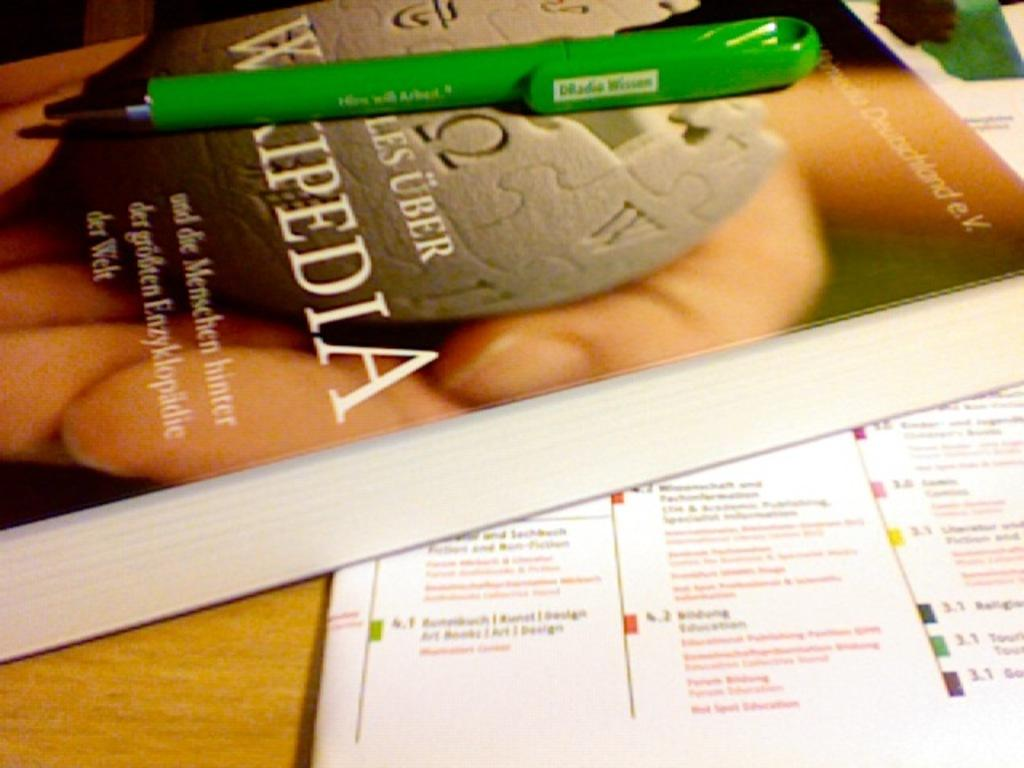<image>
Write a terse but informative summary of the picture. the word Wikipedia is on the front of the book 